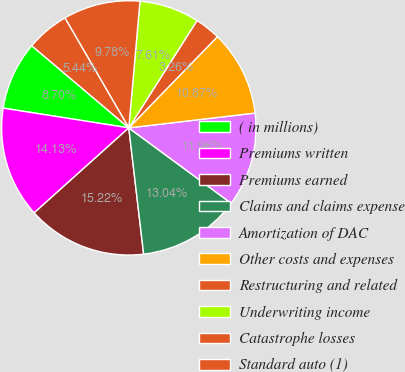Convert chart. <chart><loc_0><loc_0><loc_500><loc_500><pie_chart><fcel>( in millions)<fcel>Premiums written<fcel>Premiums earned<fcel>Claims and claims expense<fcel>Amortization of DAC<fcel>Other costs and expenses<fcel>Restructuring and related<fcel>Underwriting income<fcel>Catastrophe losses<fcel>Standard auto (1)<nl><fcel>8.7%<fcel>14.13%<fcel>15.22%<fcel>13.04%<fcel>11.96%<fcel>10.87%<fcel>3.26%<fcel>7.61%<fcel>9.78%<fcel>5.44%<nl></chart> 